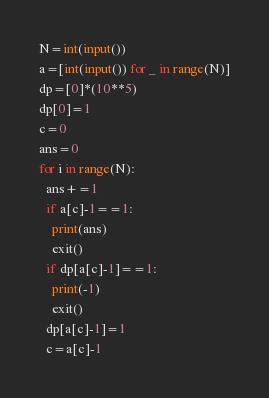<code> <loc_0><loc_0><loc_500><loc_500><_Python_>N=int(input())
a=[int(input()) for _ in range(N)]
dp=[0]*(10**5)
dp[0]=1
c=0
ans=0
for i in range(N):
  ans+=1
  if a[c]-1==1:
    print(ans)
    exit()
  if dp[a[c]-1]==1:
    print(-1)
    exit()
  dp[a[c]-1]=1
  c=a[c]-1</code> 